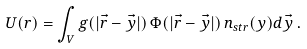<formula> <loc_0><loc_0><loc_500><loc_500>U ( r ) = \int _ { V } g ( | \vec { r } - \vec { y } | ) \, \Phi ( | \vec { r } - \vec { y } | ) \, n _ { s t r } ( y ) d \vec { y } \, .</formula> 